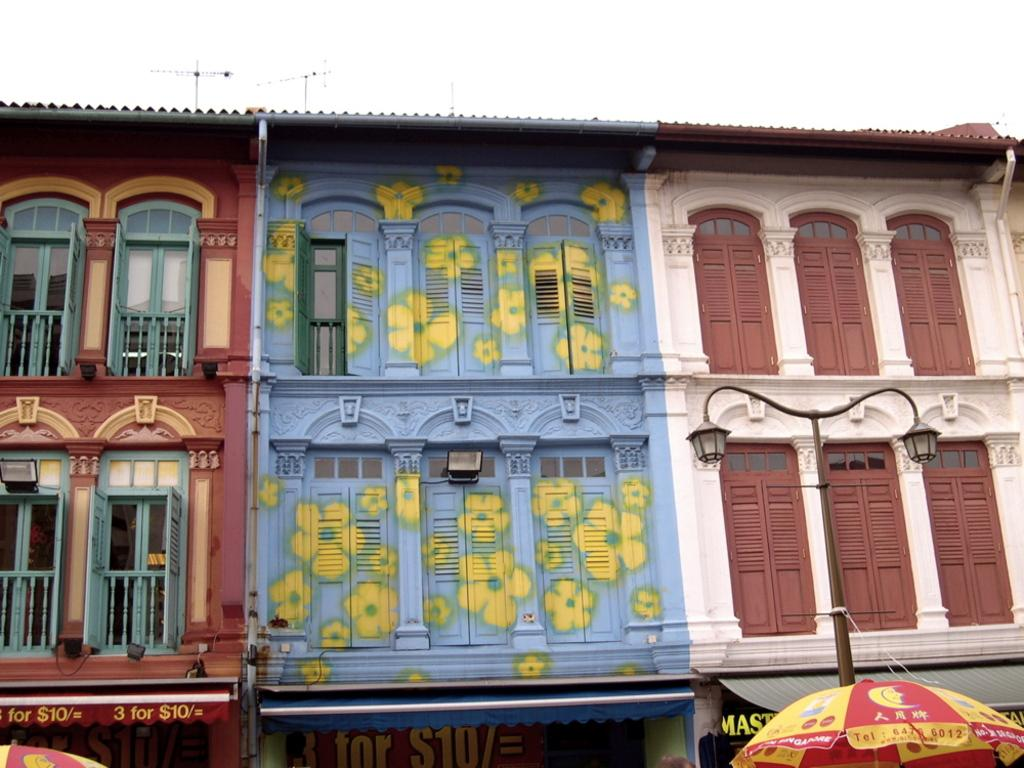What can be seen in the sky in the image? There is a sky in the image. What type of structures are present in the image? There are buildings in the image. What feature do the buildings have? The buildings have lights and windows. What type of lighting is present on the street in the image? There is a street light in the image. What type of establishment can be found in the image? There are shops in the image. What object is being used to protect against the weather in the image? There is an umbrella in the image. Can you see a ball being played with in the image? There is no ball present in the image. Is there a tent set up in the image? There is no tent present in the image. 